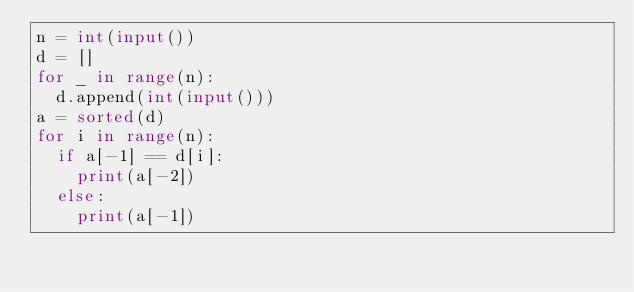Convert code to text. <code><loc_0><loc_0><loc_500><loc_500><_Python_>n = int(input())
d = []
for _ in range(n):
  d.append(int(input()))
a = sorted(d)
for i in range(n):
  if a[-1] == d[i]:
    print(a[-2])
  else:
    print(a[-1])</code> 